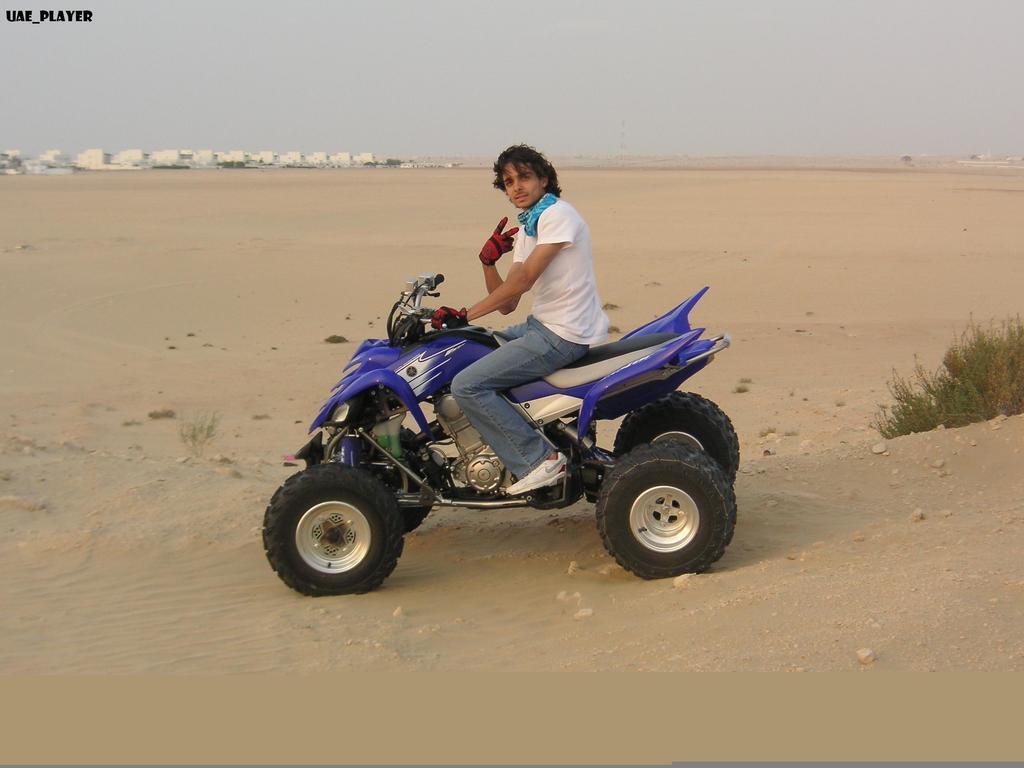In one or two sentences, can you explain what this image depicts? In this image in the center there is one person who is sitting on a vehicle, and at the bottom there is sand and some plants. In the background there are some buildings, and at the top of the image there is sky. 